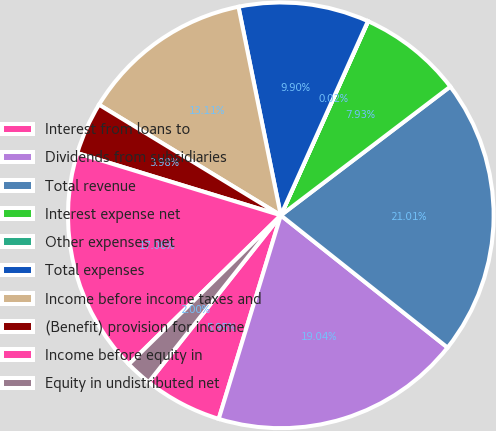Convert chart. <chart><loc_0><loc_0><loc_500><loc_500><pie_chart><fcel>Interest from loans to<fcel>Dividends from subsidiaries<fcel>Total revenue<fcel>Interest expense net<fcel>Other expenses net<fcel>Total expenses<fcel>Income before income taxes and<fcel>(Benefit) provision for income<fcel>Income before equity in<fcel>Equity in undistributed net<nl><fcel>5.95%<fcel>19.04%<fcel>21.01%<fcel>7.93%<fcel>0.02%<fcel>9.9%<fcel>13.11%<fcel>3.98%<fcel>17.06%<fcel>2.0%<nl></chart> 